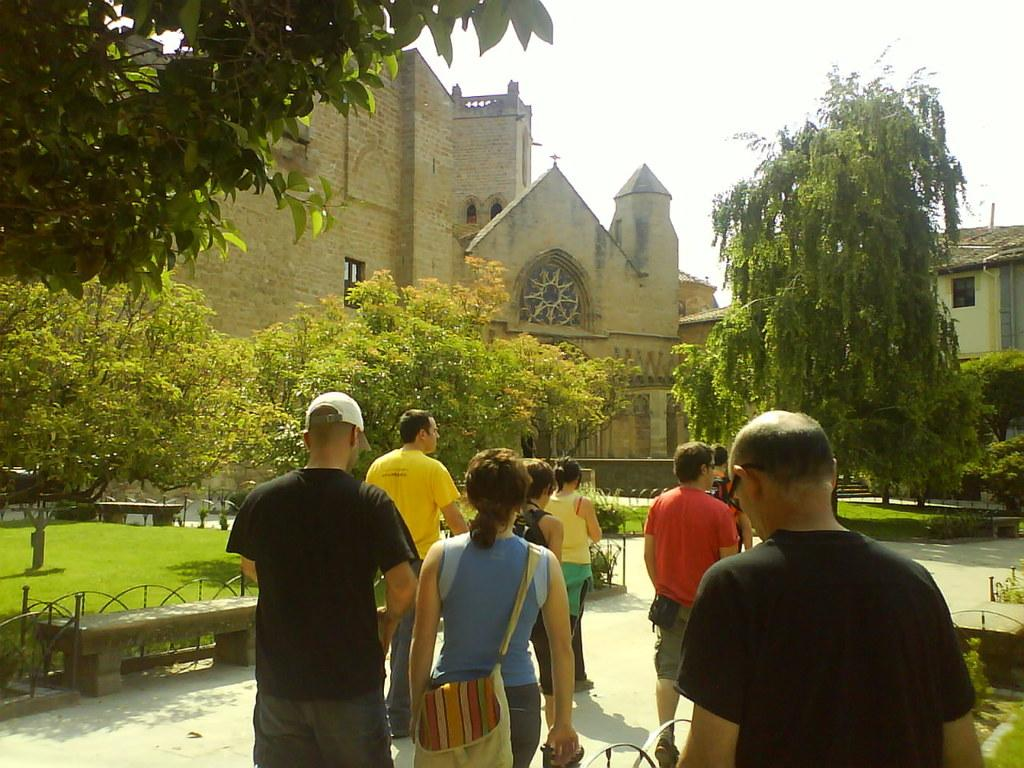How many people are in the image? There is a group of people in the image. What are the people doing in the image? The people are on a path. What items can be seen with the people in the image? There are bags and caps visible in the image. What type of seating is present in the image? There are benches in the image. What type of ground surface is visible in the image? There is grass in the image. What type of vegetation is present in the image? There are trees in the image. What type of structures are visible in the image? There are buildings with windows in the image. What type of barrier is present in the image? There are fences in the image. What is visible in the background of the image? The sky is visible in the background of the image. What type of jeans are the fowl wearing in the image? There are no fowl or jeans present in the image. 